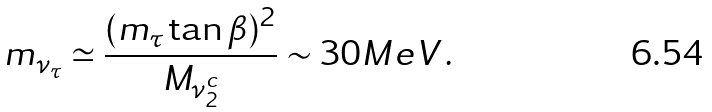<formula> <loc_0><loc_0><loc_500><loc_500>m _ { \nu _ { \tau } } \simeq \frac { ( m _ { \tau } \tan \beta ) ^ { 2 } } { M _ { \nu _ { 2 } ^ { c } } } \sim 3 0 M e V \, .</formula> 